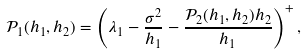<formula> <loc_0><loc_0><loc_500><loc_500>\mathcal { P } _ { 1 } ( h _ { 1 } , h _ { 2 } ) = \left ( \lambda _ { 1 } - \frac { \sigma ^ { 2 } } { h _ { 1 } } - \frac { \mathcal { P } _ { 2 } ( h _ { 1 } , h _ { 2 } ) h _ { 2 } } { h _ { 1 } } \right ) ^ { + } ,</formula> 